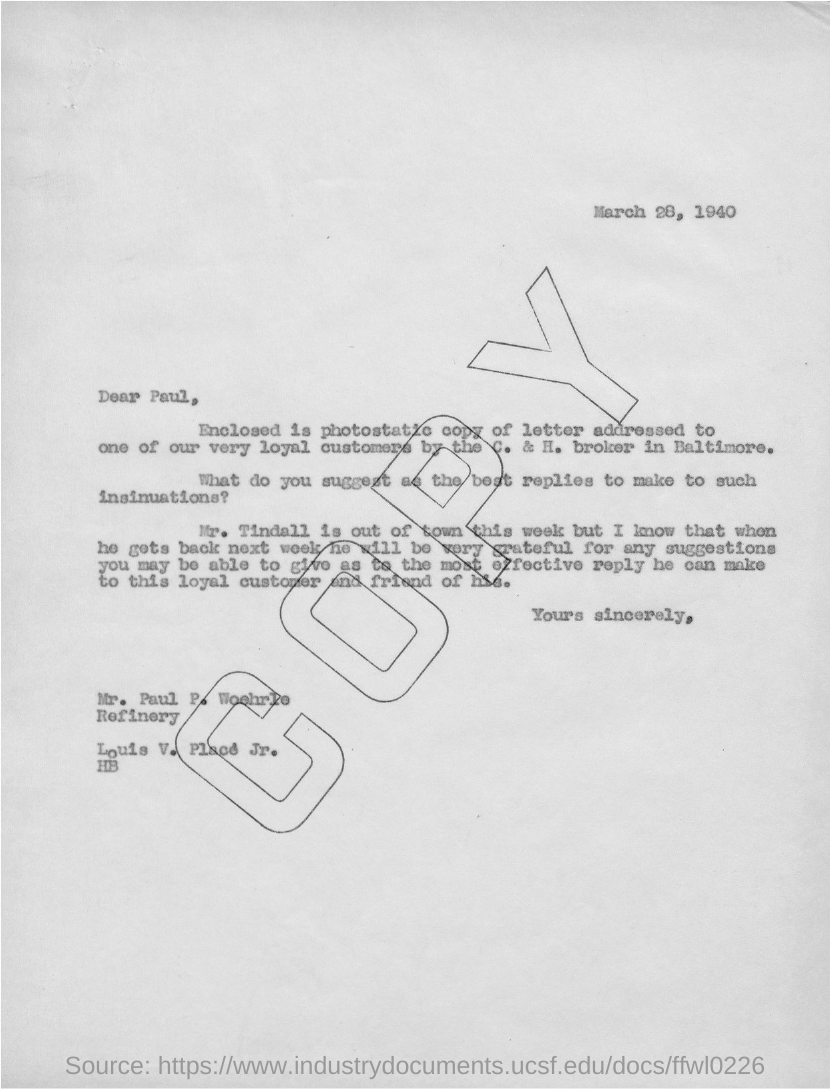What is the date mentioned in this letter?
Offer a very short reply. March 28, 1940. 